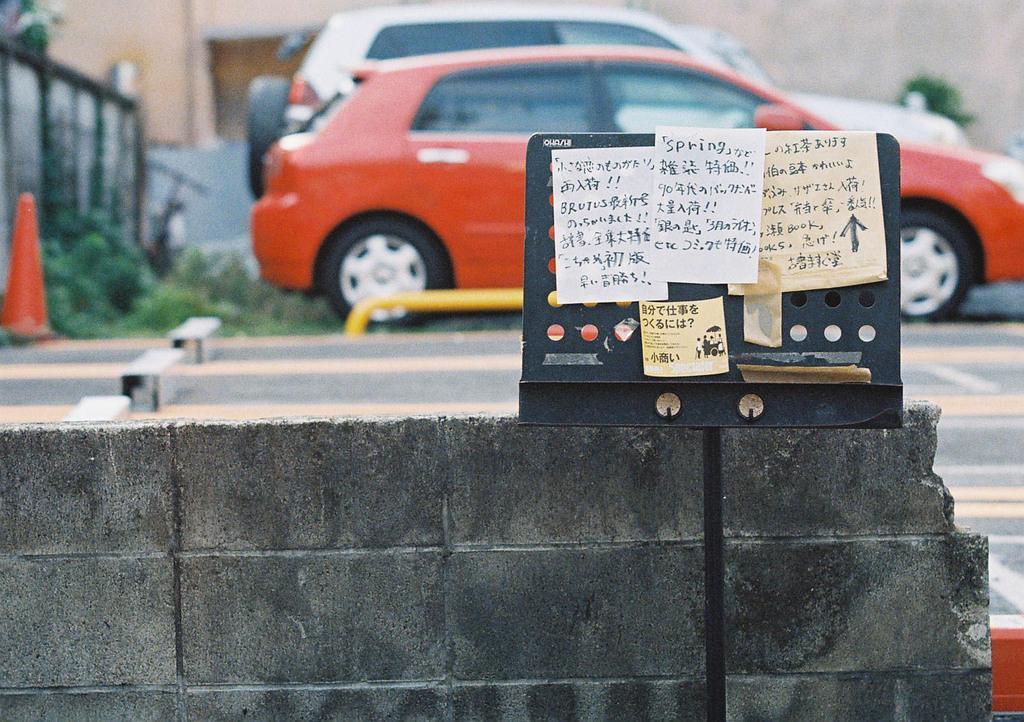Can you describe this image briefly? In this image, we can see some vehicles. We can see the ground with some objects and grass. We can see the wall. We can also see a black colored object with some posters. 